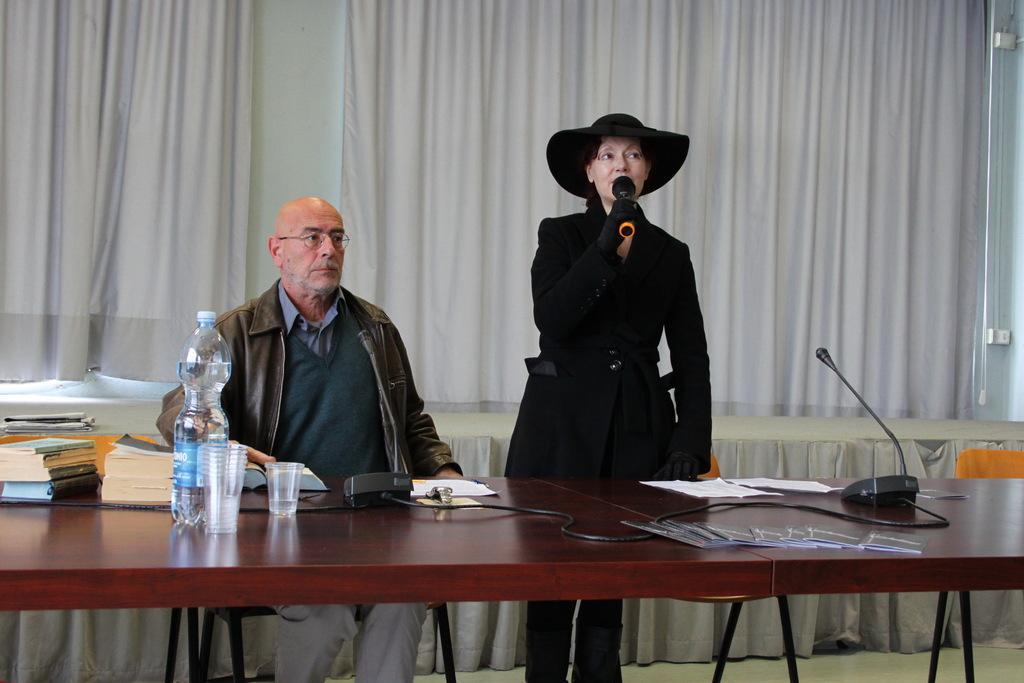In one or two sentences, can you explain what this image depicts? This picture is of inside the room. On the right there is a woman wearing black color dress, holding a microphone, standing and seems to be talking. On the left there is a man sitting on the chair and there is a table on the top of which a microphone, glasses, water bottle and books are placed. In the background we can see the wall and curtains. 